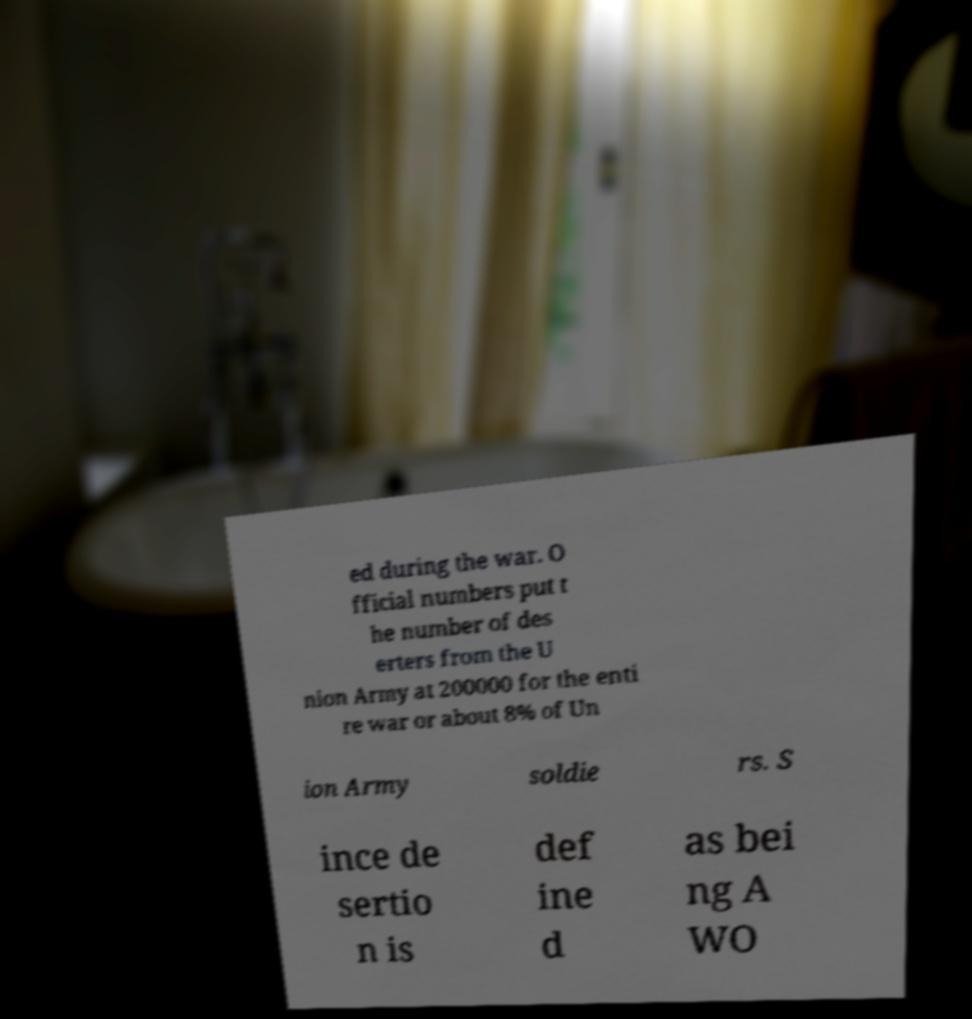Please identify and transcribe the text found in this image. ed during the war. O fficial numbers put t he number of des erters from the U nion Army at 200000 for the enti re war or about 8% of Un ion Army soldie rs. S ince de sertio n is def ine d as bei ng A WO 